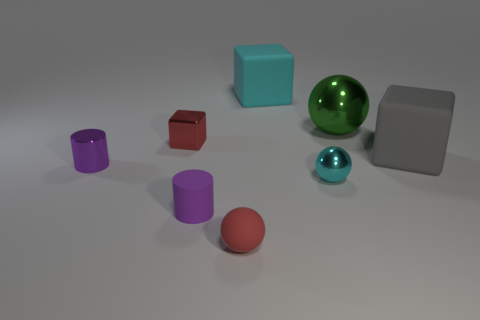Do the metal sphere that is in front of the large green ball and the ball that is on the left side of the big cyan matte cube have the same size?
Make the answer very short. Yes. Is the shape of the big cyan object the same as the big green metallic object?
Offer a very short reply. No. How many things are either cylinders behind the tiny cyan metallic sphere or large green metallic objects?
Your answer should be very brief. 2. Is there a big brown matte object that has the same shape as the small red shiny object?
Your answer should be very brief. No. Are there the same number of large objects that are behind the cyan rubber cube and tiny metal things?
Give a very brief answer. No. What is the shape of the tiny rubber object that is the same color as the small cube?
Provide a succinct answer. Sphere. What number of red objects are the same size as the gray object?
Provide a short and direct response. 0. There is a big metallic ball; how many large rubber things are behind it?
Ensure brevity in your answer.  1. What material is the small red object in front of the rubber cube that is to the right of the cyan metal sphere?
Your answer should be compact. Rubber. Is there a rubber cylinder of the same color as the large metallic object?
Provide a succinct answer. No. 